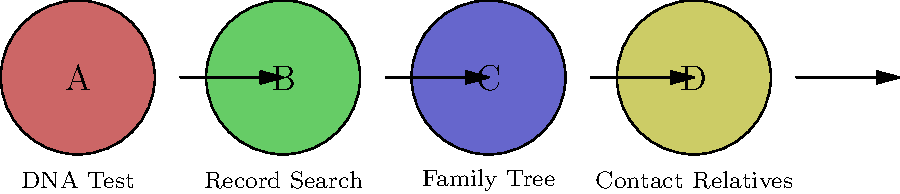In the context of genealogical research for finding biological parents, what is the correct sequence of steps represented by the colored circles? Let's analyze the steps in genealogical research for finding biological parents:

1. The first step (A) is labeled "DNA Test". This is often the starting point for individuals searching for biological parents, as it provides genetic information that can be matched with potential relatives.

2. The second step (B) is "Record Search". After obtaining DNA results, searching through various records (birth certificates, adoption records, etc.) can provide valuable information about biological parents.

3. The third step (C) is "Family Tree". Using the information from DNA tests and record searches, one can start building a family tree, connecting potential relatives and narrowing down possibilities.

4. The final step (D) is "Contact Relatives". Once potential relatives are identified through DNA matches and family tree construction, reaching out to these individuals can provide additional information and potentially lead to the biological parents.

The arrows in the diagram indicate the progression from one step to the next, confirming the sequence A → B → C → D.
Answer: A-B-C-D 